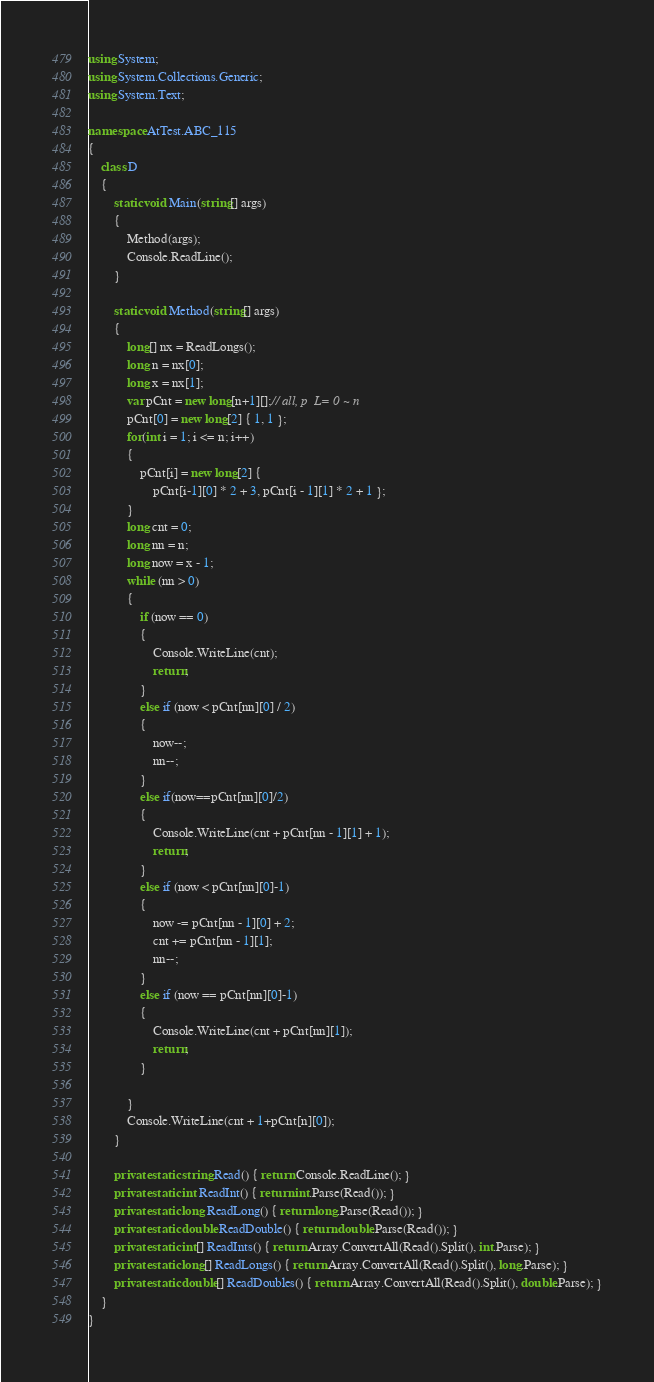Convert code to text. <code><loc_0><loc_0><loc_500><loc_500><_C#_>using System;
using System.Collections.Generic;
using System.Text;

namespace AtTest.ABC_115
{
    class D
    {
        static void Main(string[] args)
        {
            Method(args);
            Console.ReadLine();
        }

        static void Method(string[] args)
        {
            long[] nx = ReadLongs();
            long n = nx[0];
            long x = nx[1];
            var pCnt = new long[n+1][];// all, p  L= 0 ~ n
            pCnt[0] = new long[2] { 1, 1 };
            for(int i = 1; i <= n; i++)
            {
                pCnt[i] = new long[2] {
                    pCnt[i-1][0] * 2 + 3, pCnt[i - 1][1] * 2 + 1 };
            }
            long cnt = 0;
            long nn = n;
            long now = x - 1;
            while (nn > 0)
            {
                if (now == 0)
                {
                    Console.WriteLine(cnt);
                    return;
                }
                else if (now < pCnt[nn][0] / 2)
                {
                    now--;
                    nn--;
                }
                else if(now==pCnt[nn][0]/2)
                {
                    Console.WriteLine(cnt + pCnt[nn - 1][1] + 1);
                    return;
                }
                else if (now < pCnt[nn][0]-1)
                {
                    now -= pCnt[nn - 1][0] + 2;
                    cnt += pCnt[nn - 1][1];
                    nn--;
                }
                else if (now == pCnt[nn][0]-1)
                {
                    Console.WriteLine(cnt + pCnt[nn][1]);
                    return;
                }

            }
            Console.WriteLine(cnt + 1+pCnt[n][0]);
        }

        private static string Read() { return Console.ReadLine(); }
        private static int ReadInt() { return int.Parse(Read()); }
        private static long ReadLong() { return long.Parse(Read()); }
        private static double ReadDouble() { return double.Parse(Read()); }
        private static int[] ReadInts() { return Array.ConvertAll(Read().Split(), int.Parse); }
        private static long[] ReadLongs() { return Array.ConvertAll(Read().Split(), long.Parse); }
        private static double[] ReadDoubles() { return Array.ConvertAll(Read().Split(), double.Parse); }
    }
}
</code> 